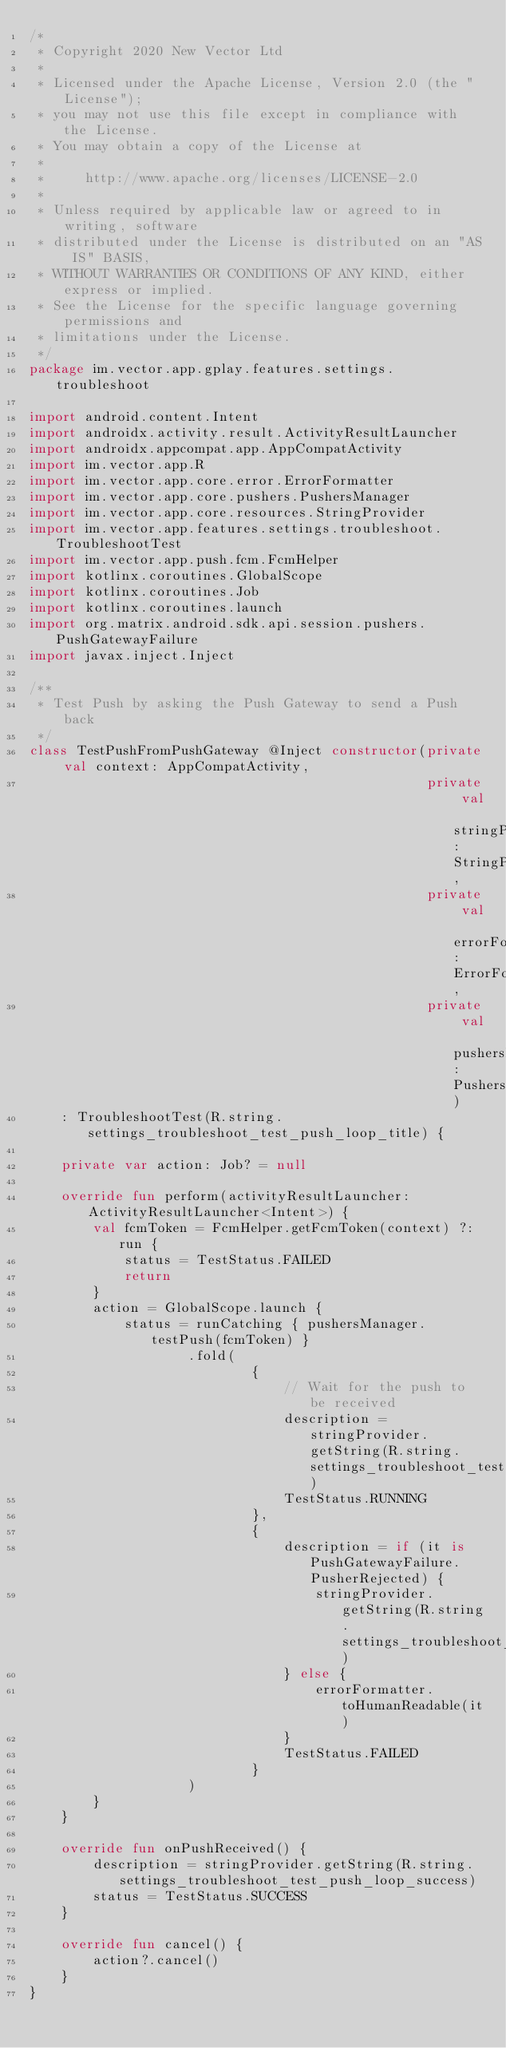Convert code to text. <code><loc_0><loc_0><loc_500><loc_500><_Kotlin_>/*
 * Copyright 2020 New Vector Ltd
 *
 * Licensed under the Apache License, Version 2.0 (the "License");
 * you may not use this file except in compliance with the License.
 * You may obtain a copy of the License at
 *
 *     http://www.apache.org/licenses/LICENSE-2.0
 *
 * Unless required by applicable law or agreed to in writing, software
 * distributed under the License is distributed on an "AS IS" BASIS,
 * WITHOUT WARRANTIES OR CONDITIONS OF ANY KIND, either express or implied.
 * See the License for the specific language governing permissions and
 * limitations under the License.
 */
package im.vector.app.gplay.features.settings.troubleshoot

import android.content.Intent
import androidx.activity.result.ActivityResultLauncher
import androidx.appcompat.app.AppCompatActivity
import im.vector.app.R
import im.vector.app.core.error.ErrorFormatter
import im.vector.app.core.pushers.PushersManager
import im.vector.app.core.resources.StringProvider
import im.vector.app.features.settings.troubleshoot.TroubleshootTest
import im.vector.app.push.fcm.FcmHelper
import kotlinx.coroutines.GlobalScope
import kotlinx.coroutines.Job
import kotlinx.coroutines.launch
import org.matrix.android.sdk.api.session.pushers.PushGatewayFailure
import javax.inject.Inject

/**
 * Test Push by asking the Push Gateway to send a Push back
 */
class TestPushFromPushGateway @Inject constructor(private val context: AppCompatActivity,
                                                  private val stringProvider: StringProvider,
                                                  private val errorFormatter: ErrorFormatter,
                                                  private val pushersManager: PushersManager)
    : TroubleshootTest(R.string.settings_troubleshoot_test_push_loop_title) {

    private var action: Job? = null

    override fun perform(activityResultLauncher: ActivityResultLauncher<Intent>) {
        val fcmToken = FcmHelper.getFcmToken(context) ?: run {
            status = TestStatus.FAILED
            return
        }
        action = GlobalScope.launch {
            status = runCatching { pushersManager.testPush(fcmToken) }
                    .fold(
                            {
                                // Wait for the push to be received
                                description = stringProvider.getString(R.string.settings_troubleshoot_test_push_loop_waiting_for_push)
                                TestStatus.RUNNING
                            },
                            {
                                description = if (it is PushGatewayFailure.PusherRejected) {
                                    stringProvider.getString(R.string.settings_troubleshoot_test_push_loop_failed)
                                } else {
                                    errorFormatter.toHumanReadable(it)
                                }
                                TestStatus.FAILED
                            }
                    )
        }
    }

    override fun onPushReceived() {
        description = stringProvider.getString(R.string.settings_troubleshoot_test_push_loop_success)
        status = TestStatus.SUCCESS
    }

    override fun cancel() {
        action?.cancel()
    }
}
</code> 